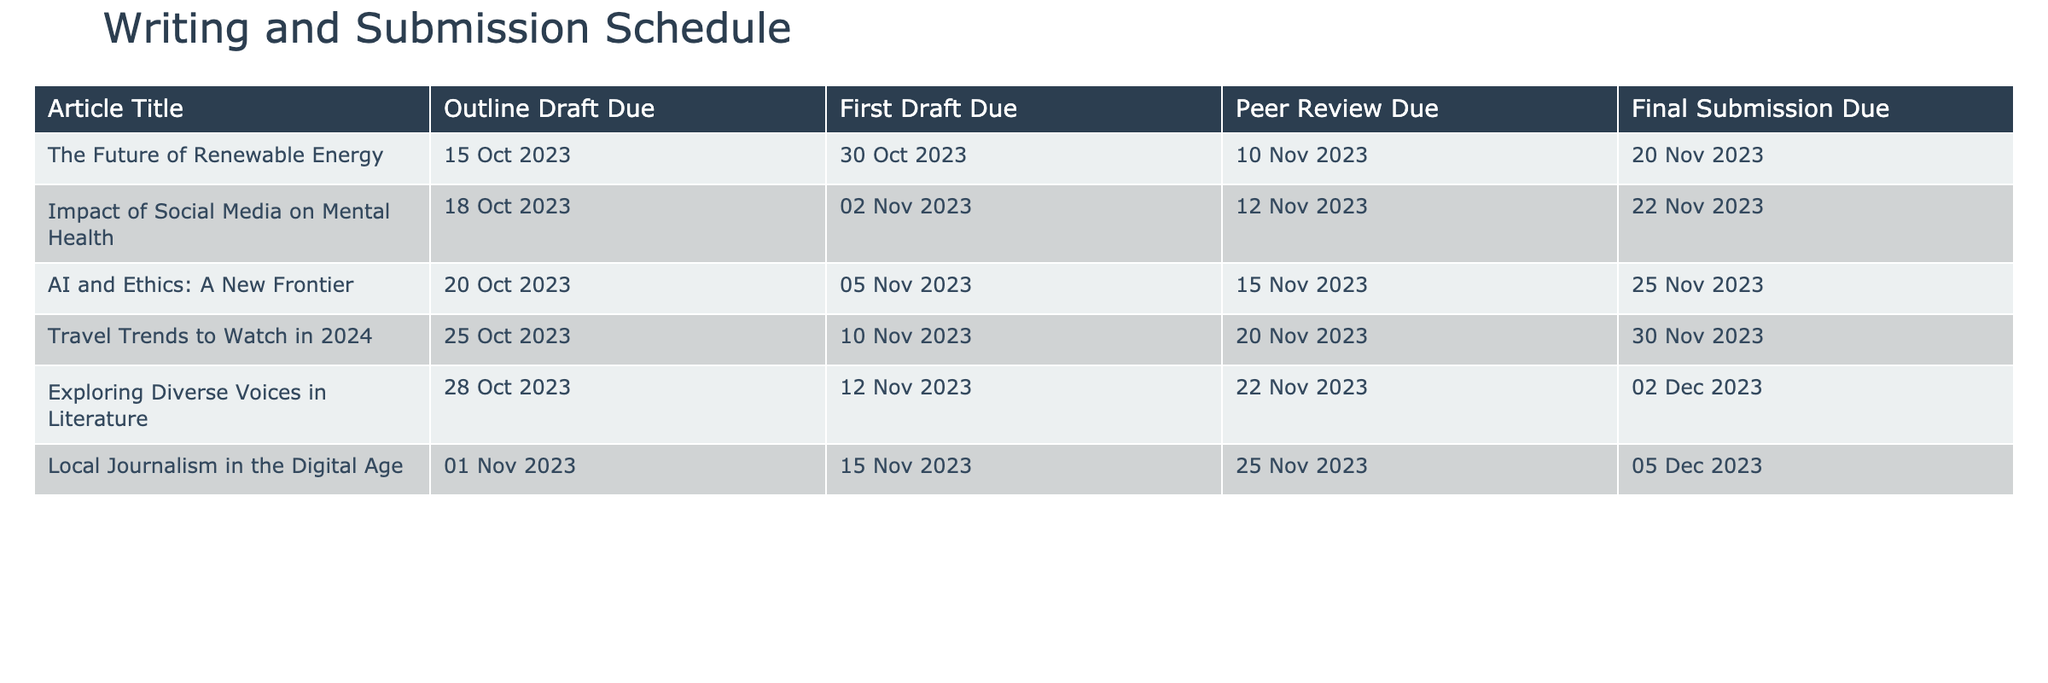What is the due date for the outline draft of "AI and Ethics: A New Frontier"? According to the table, the due date for the outline draft of "AI and Ethics: A New Frontier" is listed as 20 October 2023.
Answer: 20 October 2023 Which article has the latest final submission due date? Looking at the final submission due dates of all articles, "Exploring Diverse Voices in Literature" has the latest date of 2 December 2023.
Answer: "Exploring Diverse Voices in Literature" What is the average due date for the first drafts of all articles? By examining the first draft due dates (30 October, 2 November, 5 November, 10 November, 12 November, and 15 November), we convert them to a date format and find the average date is approximately 7 November 2023.
Answer: 7 November 2023 Is the due date for the peer review of "Impact of Social Media on Mental Health" later than the due date for final submission? The peer review due date for this article is 12 November 2023, while the final submission due date is 22 November 2023. Since 12 November is earlier than 22 November, the answer is no.
Answer: No How many days are there between the outline draft due date and the final submission due date for "The Future of Renewable Energy"? The outline draft is due on 15 October 2023 and the final submission is due on 20 November 2023. The total days between these two dates is 36 days.
Answer: 36 days What is the difference in days between the outline draft due date and the first draft due date for "Local Journalism in the Digital Age"? The outline draft for this article is due on 1 November 2023, and the first draft is due on 15 November 2023. The difference in days between these dates is 14 days.
Answer: 14 days Are there any articles that have the same due date for the final submission? The final submission due dates are unique across all articles, meaning no articles share the same date. Therefore, the answer is no.
Answer: No Which article will have its peer review due the closest to its first draft due date? By analyzing the peer review and first draft due dates, the articles "AI and Ethics: A New Frontier" and "Travel Trends to Watch in 2024" both have peer reviews due 10 and 10 days after their respective first drafts. Therefore, they share the closest proximity.
Answer: "AI and Ethics: A New Frontier" and "Travel Trends to Watch in 2024" 